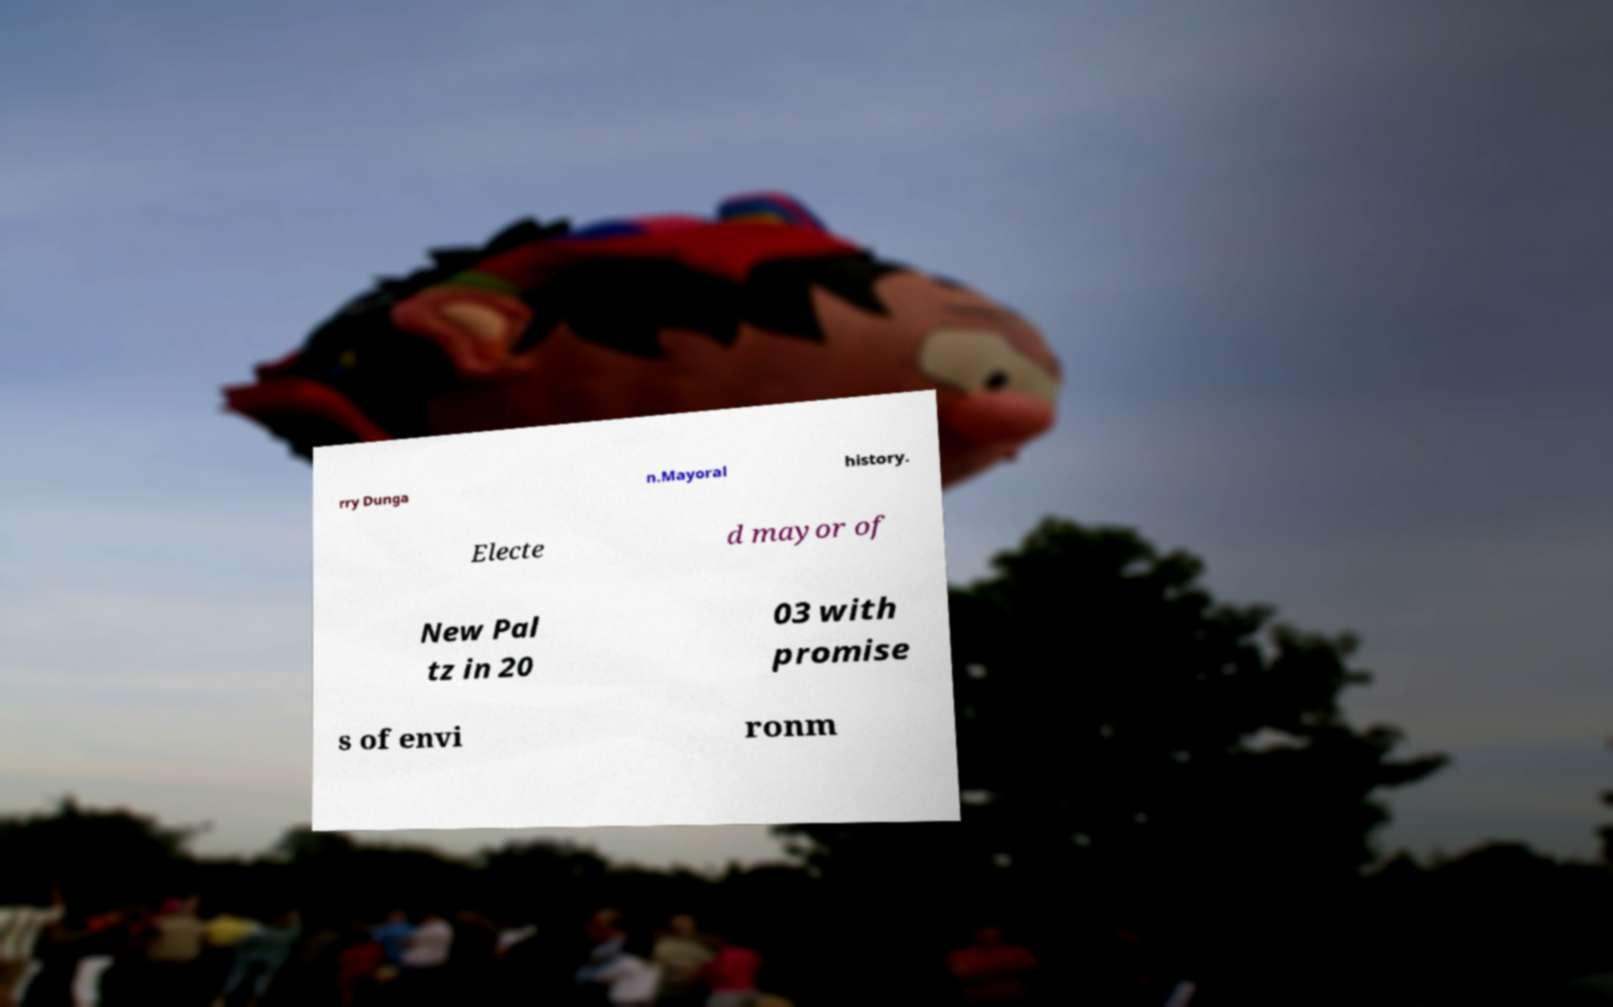Can you read and provide the text displayed in the image?This photo seems to have some interesting text. Can you extract and type it out for me? rry Dunga n.Mayoral history. Electe d mayor of New Pal tz in 20 03 with promise s of envi ronm 